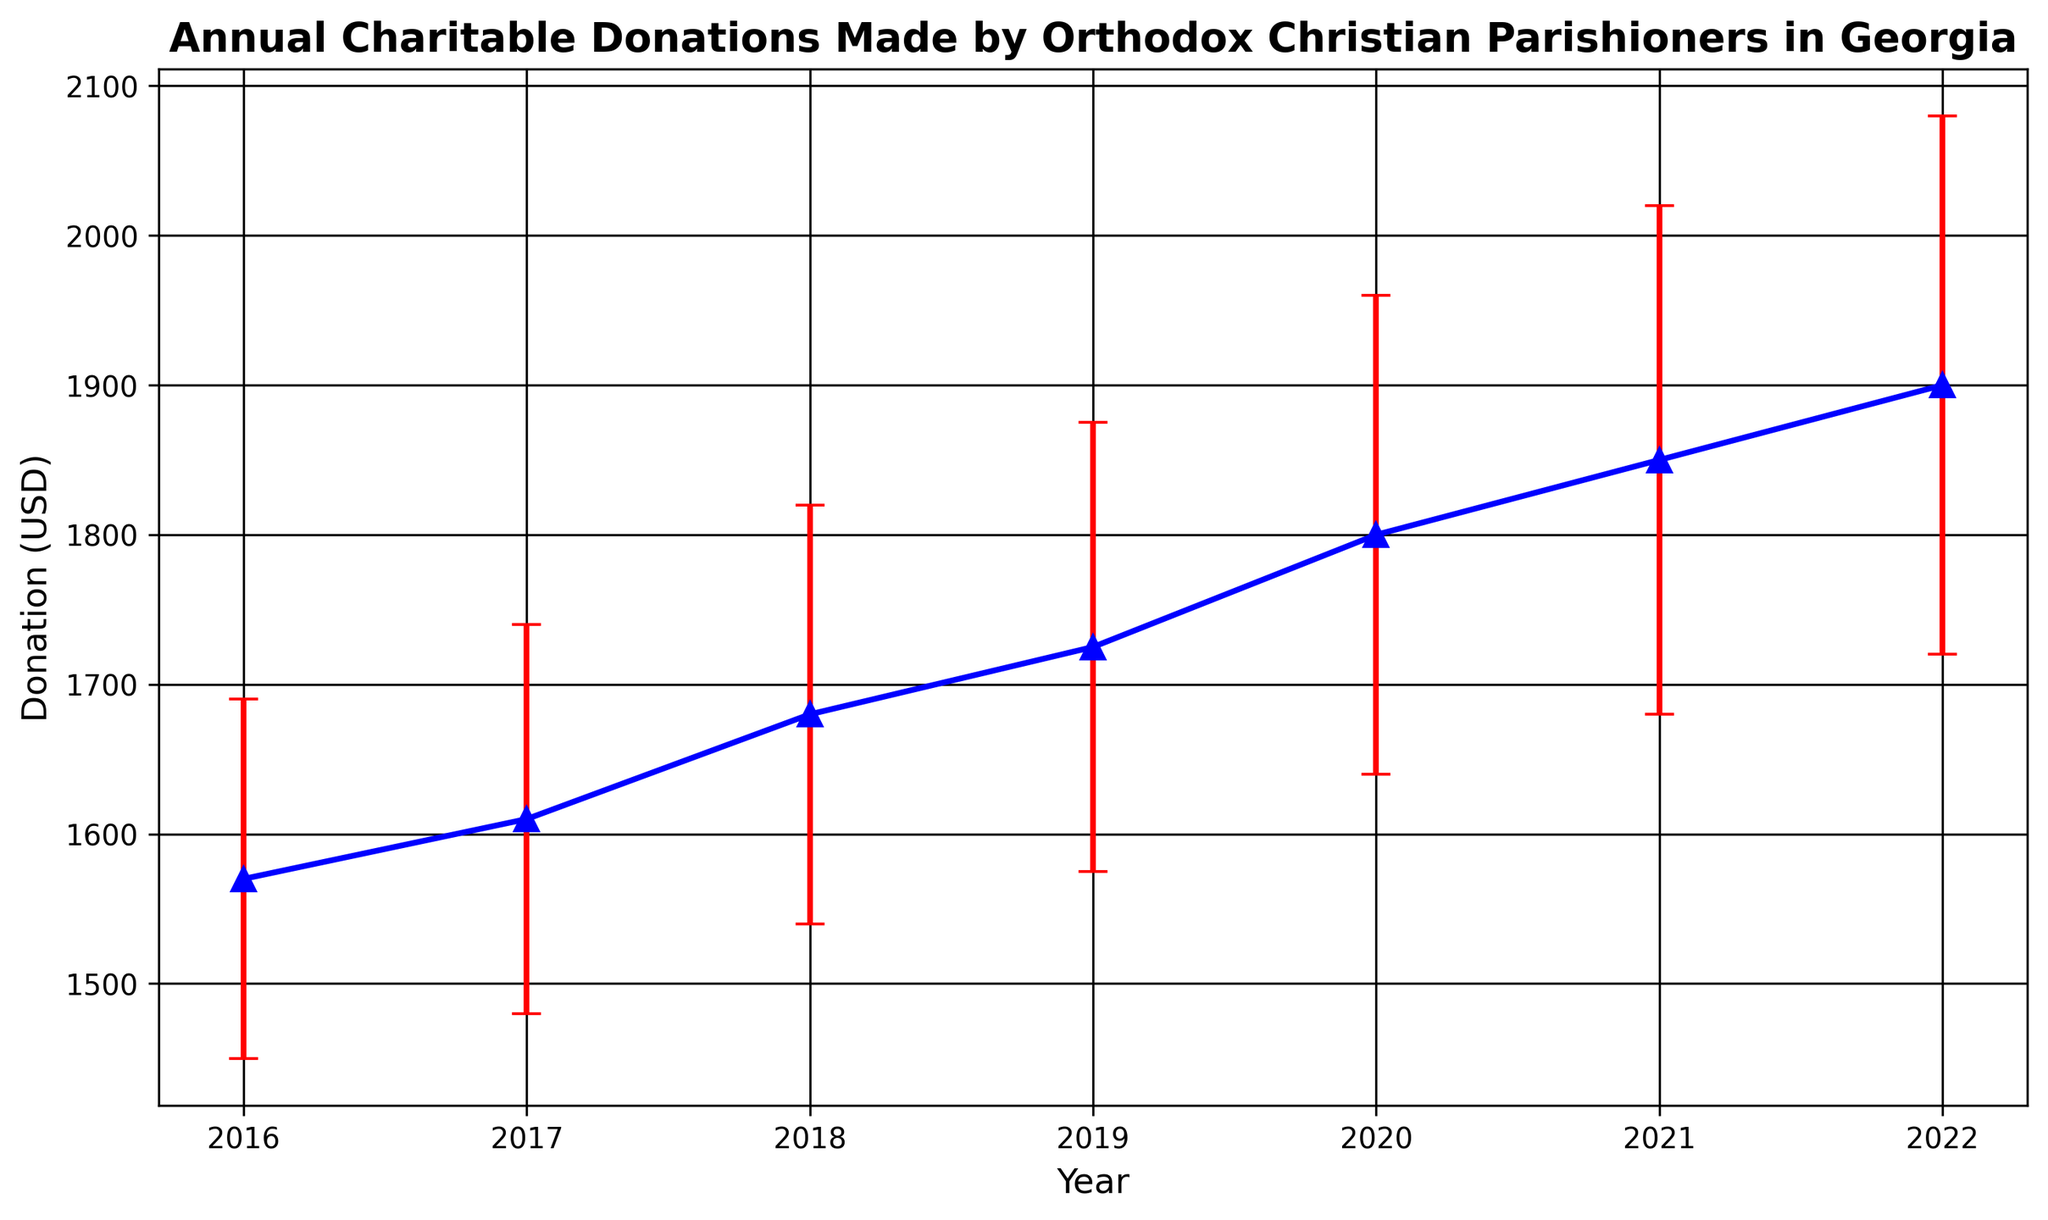What is the total amount donated in 2019 and 2020 combined? The donations for 2019 and 2020 are $1725 and $1800, respectively. Summing these amounts gives us 1725 + 180 = 3,525.
Answer: 3,525 How does the donation in 2018 compare to the donation in 2022? The donation in 2018 is $1680, and the donation in 2022 is $1900. Comparing these values, 1900 > 1680.
Answer: The donation in 2022 is greater than in 2018 Which year had the highest standard error? From the data, the highest standard error is in 2022 with an error of $180.
Answer: 2022 Is the donation in 2017 closer to the donation in 2016 or 2018? The donation in 2017 is $1610, in 2016 it is $1570, and in 2018 it is $1680. The difference from 2017 to 2016 is 1610 - 1570 = 40, and from 2017 to 2018 it is 1680 - 1610 = 70. 40 < 70, so 2017 is closer to 2016.
Answer: 2016 What is the average donation from 2016 to 2022? The donations from 2016 to 2022 are $1570, $1610, $1680, $1725, $1800, $1850, and $1900. Summing these gives 1570 + 1610 + 1680 + 1725 + 1800 + 1850 + 1900 = 12,135. There are 7 years [sum/years]. 12,135 / 7 gives approximately $1733.57.
Answer: 1733.57 